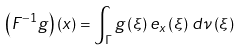Convert formula to latex. <formula><loc_0><loc_0><loc_500><loc_500>\left ( F ^ { - 1 } g \right ) \left ( x \right ) = \int _ { \Gamma } g \left ( \xi \right ) e _ { x } \left ( \xi \right ) \, d \nu \left ( \xi \right )</formula> 